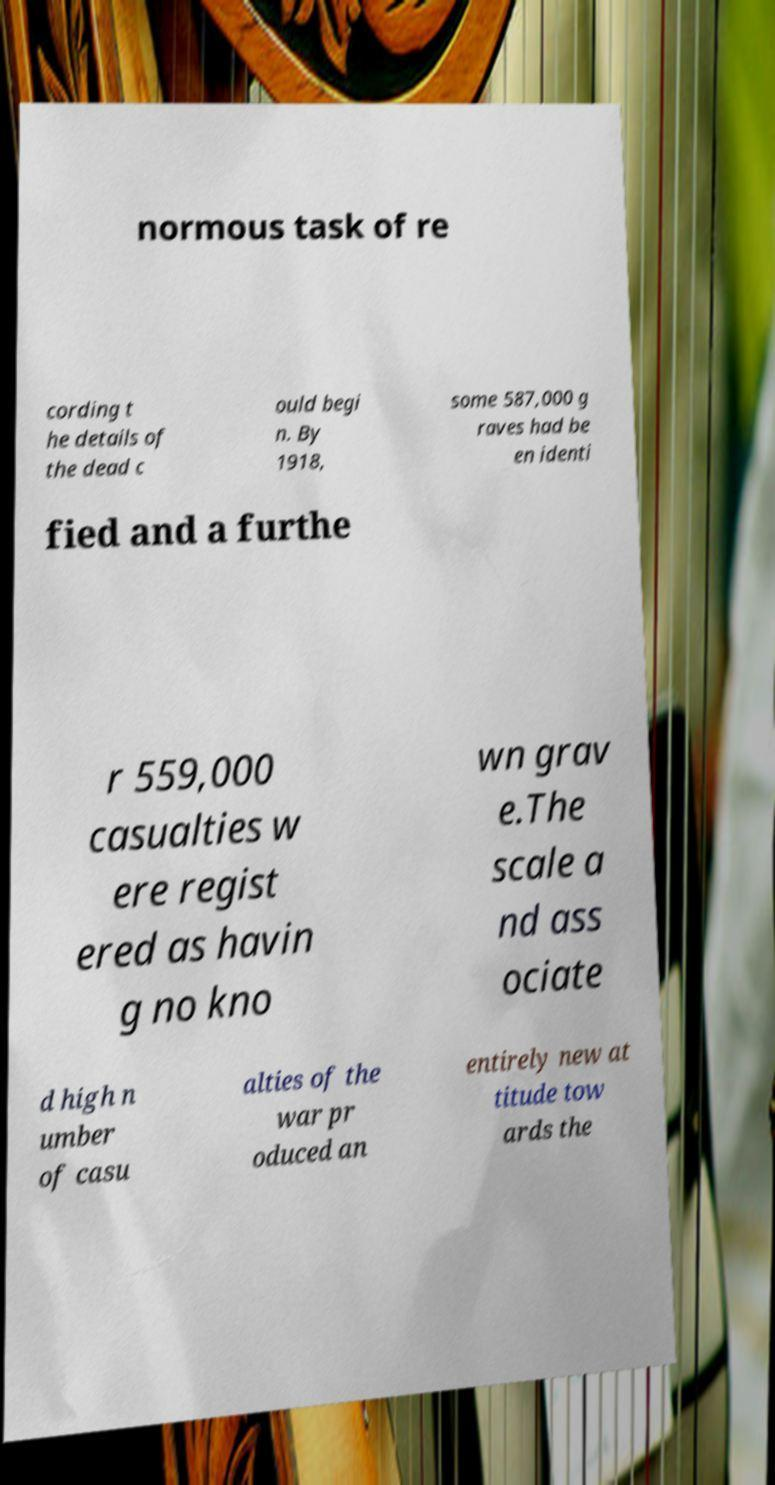Could you extract and type out the text from this image? normous task of re cording t he details of the dead c ould begi n. By 1918, some 587,000 g raves had be en identi fied and a furthe r 559,000 casualties w ere regist ered as havin g no kno wn grav e.The scale a nd ass ociate d high n umber of casu alties of the war pr oduced an entirely new at titude tow ards the 